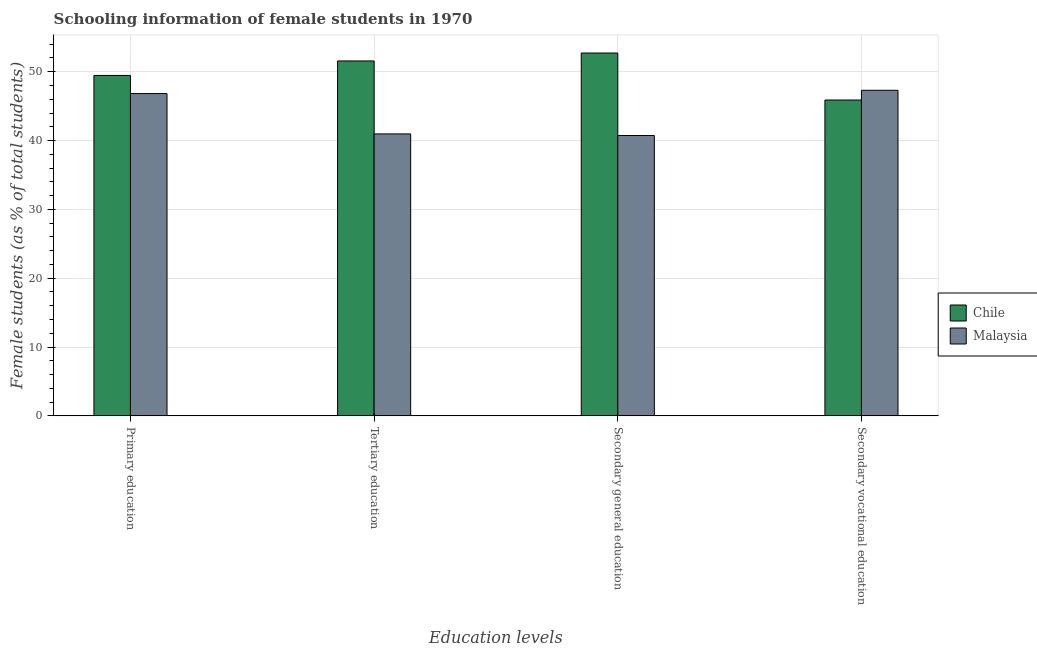How many different coloured bars are there?
Give a very brief answer. 2. How many groups of bars are there?
Give a very brief answer. 4. How many bars are there on the 3rd tick from the left?
Offer a terse response. 2. What is the label of the 1st group of bars from the left?
Provide a succinct answer. Primary education. What is the percentage of female students in primary education in Malaysia?
Provide a short and direct response. 46.83. Across all countries, what is the maximum percentage of female students in tertiary education?
Give a very brief answer. 51.57. Across all countries, what is the minimum percentage of female students in secondary education?
Your answer should be compact. 40.74. In which country was the percentage of female students in tertiary education maximum?
Give a very brief answer. Chile. In which country was the percentage of female students in primary education minimum?
Give a very brief answer. Malaysia. What is the total percentage of female students in secondary vocational education in the graph?
Provide a succinct answer. 93.2. What is the difference between the percentage of female students in primary education in Chile and that in Malaysia?
Keep it short and to the point. 2.63. What is the difference between the percentage of female students in secondary vocational education in Chile and the percentage of female students in tertiary education in Malaysia?
Your answer should be very brief. 4.93. What is the average percentage of female students in secondary vocational education per country?
Provide a succinct answer. 46.6. What is the difference between the percentage of female students in secondary vocational education and percentage of female students in tertiary education in Malaysia?
Give a very brief answer. 6.34. What is the ratio of the percentage of female students in secondary vocational education in Malaysia to that in Chile?
Provide a succinct answer. 1.03. Is the difference between the percentage of female students in primary education in Malaysia and Chile greater than the difference between the percentage of female students in secondary vocational education in Malaysia and Chile?
Ensure brevity in your answer.  No. What is the difference between the highest and the second highest percentage of female students in secondary vocational education?
Offer a terse response. 1.41. What is the difference between the highest and the lowest percentage of female students in secondary vocational education?
Your response must be concise. 1.41. In how many countries, is the percentage of female students in secondary education greater than the average percentage of female students in secondary education taken over all countries?
Your answer should be very brief. 1. Is the sum of the percentage of female students in secondary vocational education in Chile and Malaysia greater than the maximum percentage of female students in primary education across all countries?
Offer a terse response. Yes. Is it the case that in every country, the sum of the percentage of female students in primary education and percentage of female students in secondary education is greater than the sum of percentage of female students in tertiary education and percentage of female students in secondary vocational education?
Your answer should be compact. No. What does the 1st bar from the left in Primary education represents?
Keep it short and to the point. Chile. How many bars are there?
Your response must be concise. 8. Are all the bars in the graph horizontal?
Offer a terse response. No. How many countries are there in the graph?
Your response must be concise. 2. What is the difference between two consecutive major ticks on the Y-axis?
Your answer should be compact. 10. Does the graph contain any zero values?
Your answer should be compact. No. Does the graph contain grids?
Ensure brevity in your answer.  Yes. Where does the legend appear in the graph?
Your response must be concise. Center right. How many legend labels are there?
Offer a very short reply. 2. How are the legend labels stacked?
Provide a succinct answer. Vertical. What is the title of the graph?
Offer a very short reply. Schooling information of female students in 1970. What is the label or title of the X-axis?
Provide a succinct answer. Education levels. What is the label or title of the Y-axis?
Your response must be concise. Female students (as % of total students). What is the Female students (as % of total students) in Chile in Primary education?
Give a very brief answer. 49.46. What is the Female students (as % of total students) of Malaysia in Primary education?
Your answer should be compact. 46.83. What is the Female students (as % of total students) of Chile in Tertiary education?
Make the answer very short. 51.57. What is the Female students (as % of total students) in Malaysia in Tertiary education?
Your answer should be very brief. 40.97. What is the Female students (as % of total students) of Chile in Secondary general education?
Keep it short and to the point. 52.72. What is the Female students (as % of total students) of Malaysia in Secondary general education?
Give a very brief answer. 40.74. What is the Female students (as % of total students) in Chile in Secondary vocational education?
Keep it short and to the point. 45.89. What is the Female students (as % of total students) of Malaysia in Secondary vocational education?
Keep it short and to the point. 47.31. Across all Education levels, what is the maximum Female students (as % of total students) in Chile?
Ensure brevity in your answer.  52.72. Across all Education levels, what is the maximum Female students (as % of total students) in Malaysia?
Offer a very short reply. 47.31. Across all Education levels, what is the minimum Female students (as % of total students) of Chile?
Provide a succinct answer. 45.89. Across all Education levels, what is the minimum Female students (as % of total students) of Malaysia?
Your response must be concise. 40.74. What is the total Female students (as % of total students) of Chile in the graph?
Give a very brief answer. 199.65. What is the total Female students (as % of total students) of Malaysia in the graph?
Keep it short and to the point. 175.84. What is the difference between the Female students (as % of total students) of Chile in Primary education and that in Tertiary education?
Provide a short and direct response. -2.11. What is the difference between the Female students (as % of total students) of Malaysia in Primary education and that in Tertiary education?
Your response must be concise. 5.86. What is the difference between the Female students (as % of total students) of Chile in Primary education and that in Secondary general education?
Offer a very short reply. -3.26. What is the difference between the Female students (as % of total students) of Malaysia in Primary education and that in Secondary general education?
Provide a succinct answer. 6.09. What is the difference between the Female students (as % of total students) in Chile in Primary education and that in Secondary vocational education?
Your answer should be very brief. 3.57. What is the difference between the Female students (as % of total students) of Malaysia in Primary education and that in Secondary vocational education?
Offer a terse response. -0.48. What is the difference between the Female students (as % of total students) of Chile in Tertiary education and that in Secondary general education?
Your response must be concise. -1.15. What is the difference between the Female students (as % of total students) of Malaysia in Tertiary education and that in Secondary general education?
Offer a terse response. 0.23. What is the difference between the Female students (as % of total students) of Chile in Tertiary education and that in Secondary vocational education?
Offer a terse response. 5.68. What is the difference between the Female students (as % of total students) in Malaysia in Tertiary education and that in Secondary vocational education?
Provide a succinct answer. -6.34. What is the difference between the Female students (as % of total students) in Chile in Secondary general education and that in Secondary vocational education?
Make the answer very short. 6.83. What is the difference between the Female students (as % of total students) in Malaysia in Secondary general education and that in Secondary vocational education?
Make the answer very short. -6.57. What is the difference between the Female students (as % of total students) of Chile in Primary education and the Female students (as % of total students) of Malaysia in Tertiary education?
Provide a short and direct response. 8.49. What is the difference between the Female students (as % of total students) of Chile in Primary education and the Female students (as % of total students) of Malaysia in Secondary general education?
Offer a very short reply. 8.73. What is the difference between the Female students (as % of total students) in Chile in Primary education and the Female students (as % of total students) in Malaysia in Secondary vocational education?
Provide a short and direct response. 2.15. What is the difference between the Female students (as % of total students) of Chile in Tertiary education and the Female students (as % of total students) of Malaysia in Secondary general education?
Keep it short and to the point. 10.83. What is the difference between the Female students (as % of total students) in Chile in Tertiary education and the Female students (as % of total students) in Malaysia in Secondary vocational education?
Offer a very short reply. 4.26. What is the difference between the Female students (as % of total students) in Chile in Secondary general education and the Female students (as % of total students) in Malaysia in Secondary vocational education?
Your response must be concise. 5.41. What is the average Female students (as % of total students) in Chile per Education levels?
Give a very brief answer. 49.91. What is the average Female students (as % of total students) in Malaysia per Education levels?
Give a very brief answer. 43.96. What is the difference between the Female students (as % of total students) of Chile and Female students (as % of total students) of Malaysia in Primary education?
Your answer should be compact. 2.63. What is the difference between the Female students (as % of total students) of Chile and Female students (as % of total students) of Malaysia in Tertiary education?
Ensure brevity in your answer.  10.6. What is the difference between the Female students (as % of total students) of Chile and Female students (as % of total students) of Malaysia in Secondary general education?
Provide a short and direct response. 11.99. What is the difference between the Female students (as % of total students) of Chile and Female students (as % of total students) of Malaysia in Secondary vocational education?
Give a very brief answer. -1.41. What is the ratio of the Female students (as % of total students) of Chile in Primary education to that in Tertiary education?
Ensure brevity in your answer.  0.96. What is the ratio of the Female students (as % of total students) of Malaysia in Primary education to that in Tertiary education?
Ensure brevity in your answer.  1.14. What is the ratio of the Female students (as % of total students) in Chile in Primary education to that in Secondary general education?
Make the answer very short. 0.94. What is the ratio of the Female students (as % of total students) of Malaysia in Primary education to that in Secondary general education?
Your answer should be very brief. 1.15. What is the ratio of the Female students (as % of total students) in Chile in Primary education to that in Secondary vocational education?
Provide a succinct answer. 1.08. What is the ratio of the Female students (as % of total students) of Chile in Tertiary education to that in Secondary general education?
Provide a succinct answer. 0.98. What is the ratio of the Female students (as % of total students) of Chile in Tertiary education to that in Secondary vocational education?
Provide a short and direct response. 1.12. What is the ratio of the Female students (as % of total students) of Malaysia in Tertiary education to that in Secondary vocational education?
Your response must be concise. 0.87. What is the ratio of the Female students (as % of total students) in Chile in Secondary general education to that in Secondary vocational education?
Your response must be concise. 1.15. What is the ratio of the Female students (as % of total students) in Malaysia in Secondary general education to that in Secondary vocational education?
Your answer should be very brief. 0.86. What is the difference between the highest and the second highest Female students (as % of total students) of Chile?
Your answer should be very brief. 1.15. What is the difference between the highest and the second highest Female students (as % of total students) of Malaysia?
Give a very brief answer. 0.48. What is the difference between the highest and the lowest Female students (as % of total students) in Chile?
Give a very brief answer. 6.83. What is the difference between the highest and the lowest Female students (as % of total students) of Malaysia?
Keep it short and to the point. 6.57. 